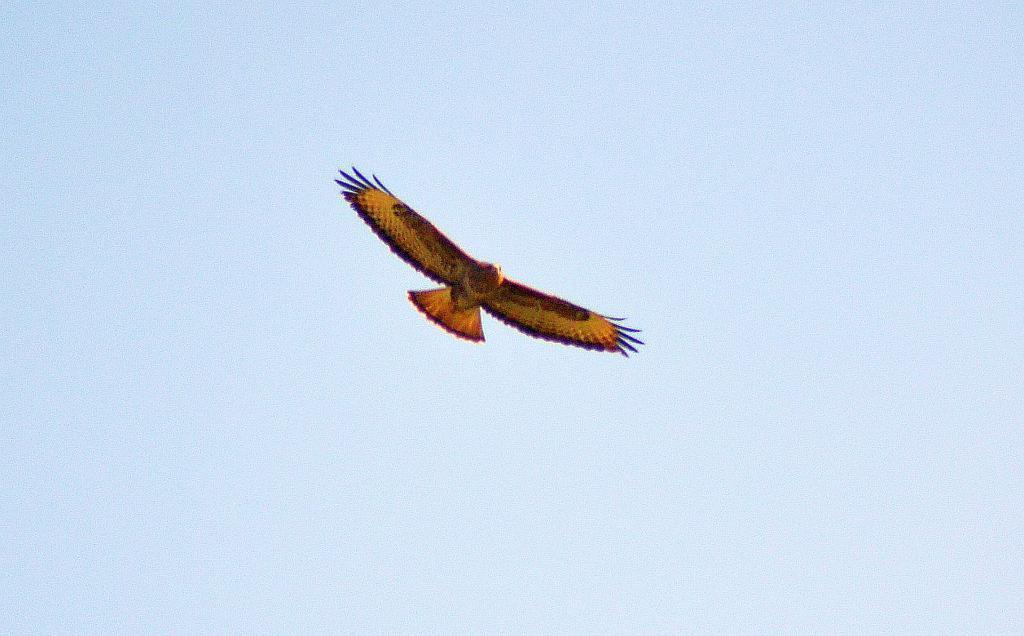Please provide a concise description of this image. In the image in the center, we can see one bird flying, which is in yellow and red color. In the background we can see the sky and clouds. 